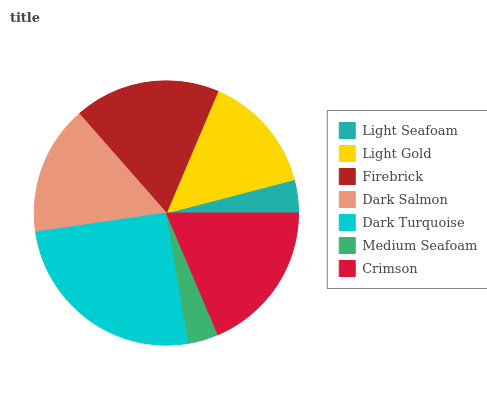Is Medium Seafoam the minimum?
Answer yes or no. Yes. Is Dark Turquoise the maximum?
Answer yes or no. Yes. Is Light Gold the minimum?
Answer yes or no. No. Is Light Gold the maximum?
Answer yes or no. No. Is Light Gold greater than Light Seafoam?
Answer yes or no. Yes. Is Light Seafoam less than Light Gold?
Answer yes or no. Yes. Is Light Seafoam greater than Light Gold?
Answer yes or no. No. Is Light Gold less than Light Seafoam?
Answer yes or no. No. Is Dark Salmon the high median?
Answer yes or no. Yes. Is Dark Salmon the low median?
Answer yes or no. Yes. Is Medium Seafoam the high median?
Answer yes or no. No. Is Crimson the low median?
Answer yes or no. No. 